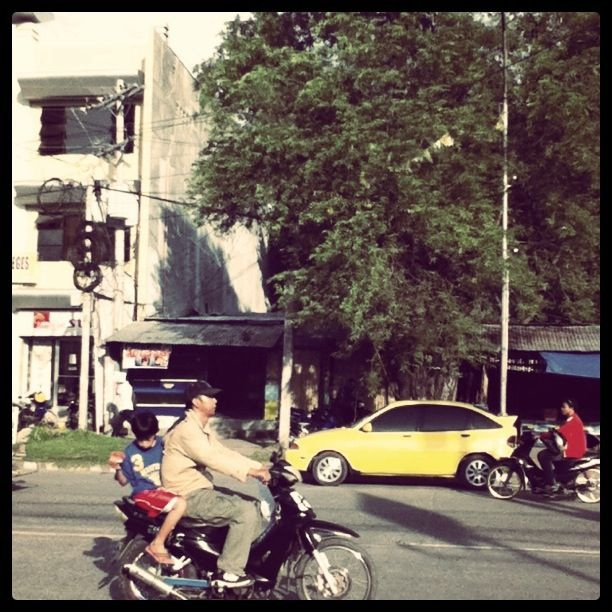Identify the text displayed in this image. 3 